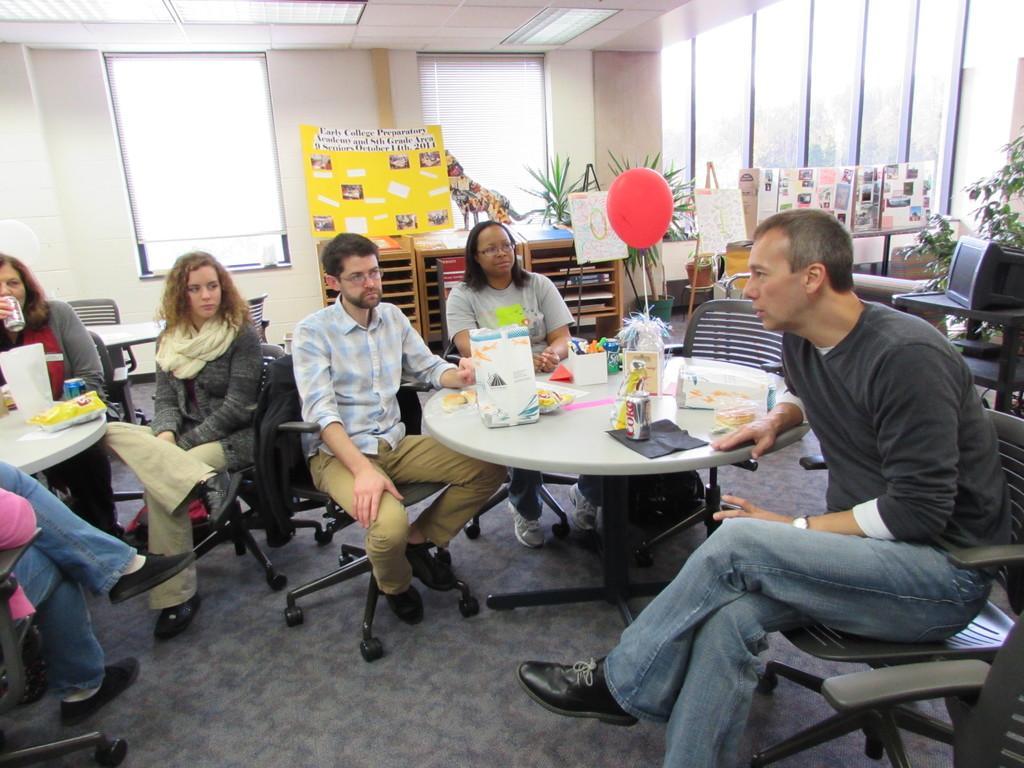How would you summarize this image in a sentence or two? There is a group of people. They are sitting on a chairs. There is a table. There is a coke and food items on a table. We can see in background curtain,window ,balloons and cupboard. 